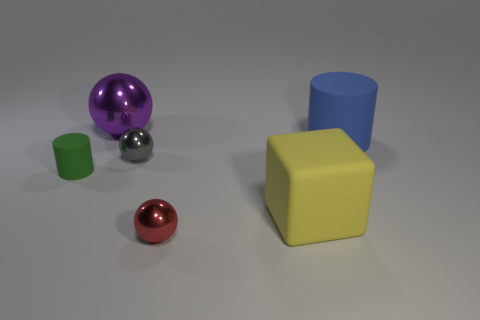Are there any purple balls left of the big yellow rubber object?
Make the answer very short. Yes. There is a metallic thing behind the big blue matte object; is its size the same as the matte cylinder that is right of the small cylinder?
Provide a succinct answer. Yes. Are there any other matte objects that have the same size as the green rubber object?
Offer a very short reply. No. There is a small red metallic thing to the right of the big ball; is its shape the same as the small green matte object?
Ensure brevity in your answer.  No. What material is the big object on the left side of the gray metal object?
Offer a very short reply. Metal. The big thing that is in front of the tiny object that is on the left side of the big ball is what shape?
Your response must be concise. Cube. Do the gray thing and the object in front of the large yellow matte thing have the same shape?
Your answer should be very brief. Yes. How many large metal spheres are on the right side of the rubber object that is left of the small red thing?
Give a very brief answer. 1. There is a tiny gray thing that is the same shape as the small red metal thing; what material is it?
Ensure brevity in your answer.  Metal. How many gray objects are spheres or tiny metal things?
Keep it short and to the point. 1. 